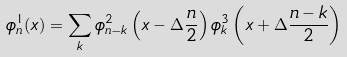<formula> <loc_0><loc_0><loc_500><loc_500>\phi ^ { 1 } _ { n } ( x ) = \sum _ { k } \phi ^ { 2 } _ { n - k } \left ( x - \Delta \frac { n } { 2 } \right ) \phi ^ { 3 } _ { k } \left ( x + \Delta \frac { n - k } { 2 } \right )</formula> 